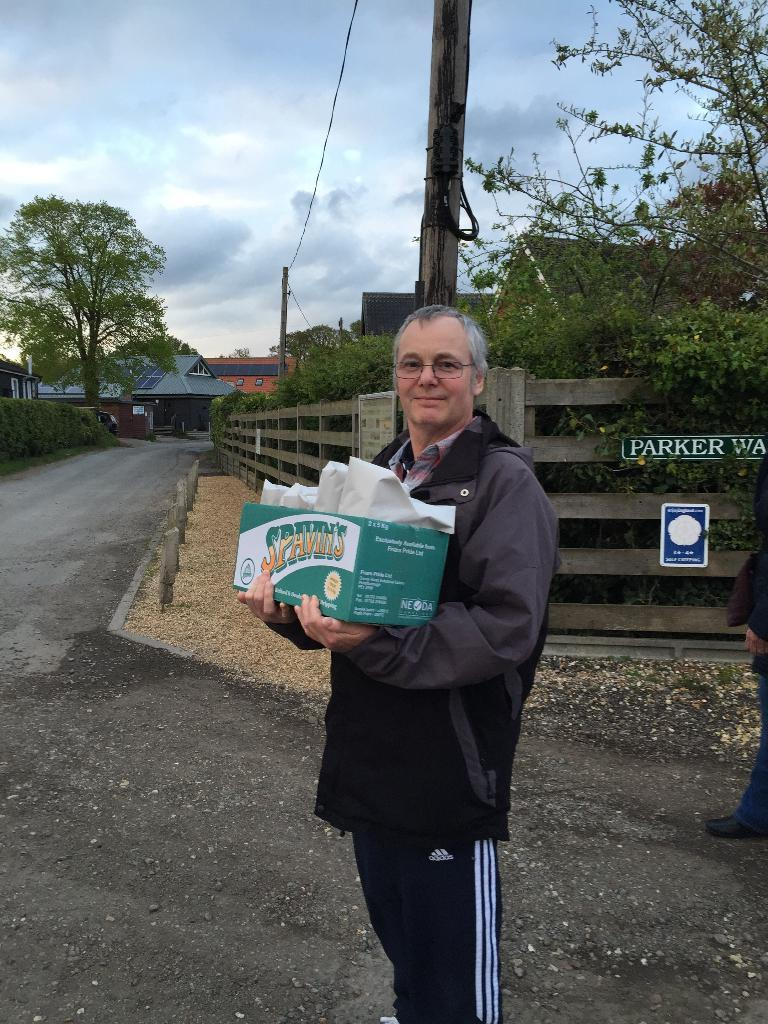What is the main feature of the image? There is a road in the image. What is the man on the road doing? The man is standing on the road and holding a box in his hand. What can be seen in the background of the image? There is wooden fencing, trees, houses, poles, and the sky visible in the background of the image. What type of form is the man filling out on the road? There is no form present in the image; the man is simply standing on the road holding a box. What kind of plough is being used to cultivate the trees in the background? There is no plough present in the image, and the trees are not being cultivated. 